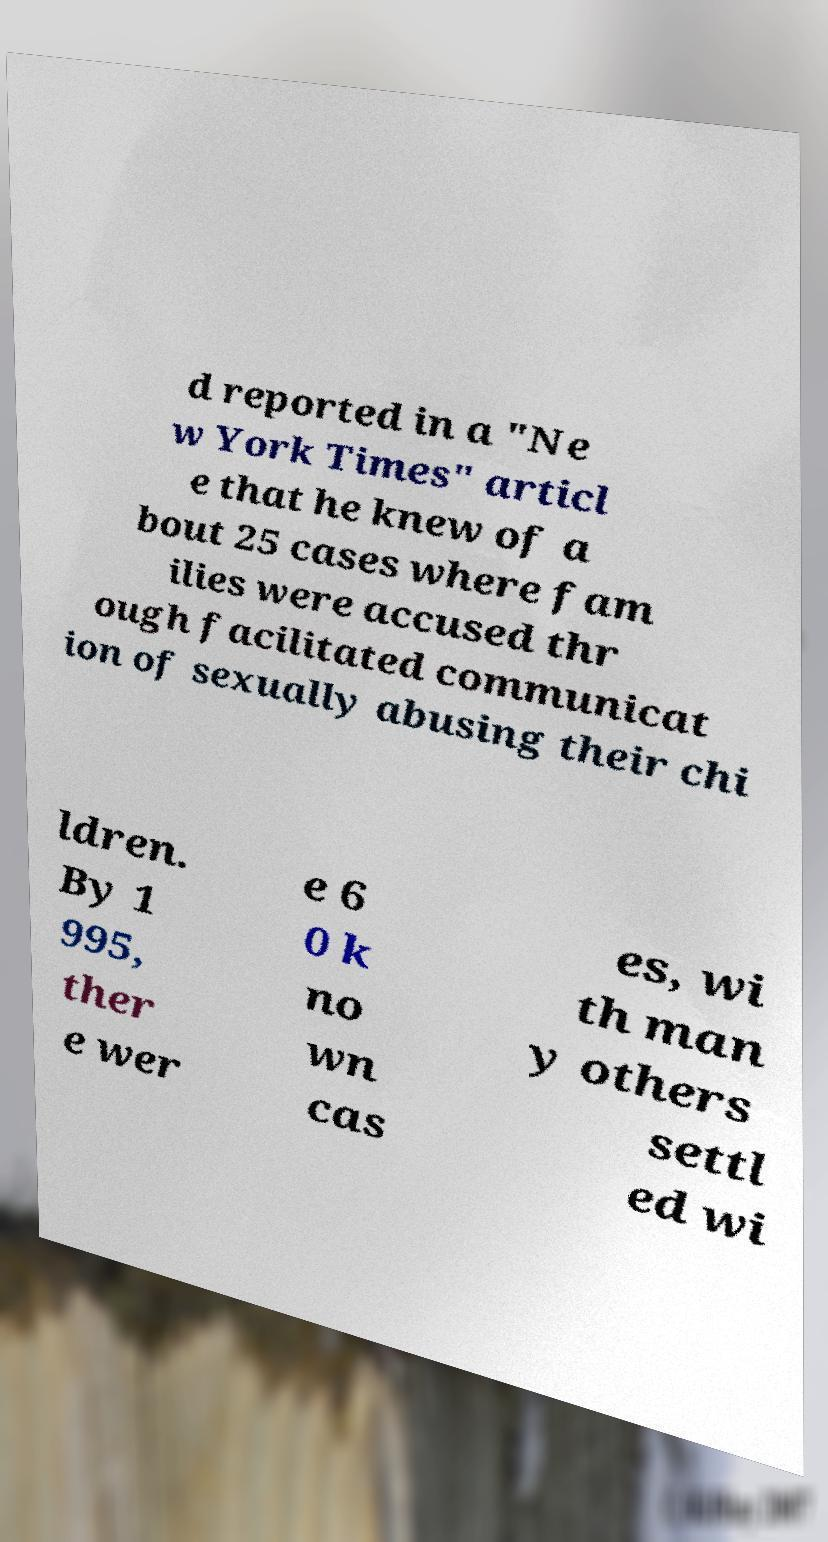There's text embedded in this image that I need extracted. Can you transcribe it verbatim? d reported in a "Ne w York Times" articl e that he knew of a bout 25 cases where fam ilies were accused thr ough facilitated communicat ion of sexually abusing their chi ldren. By 1 995, ther e wer e 6 0 k no wn cas es, wi th man y others settl ed wi 